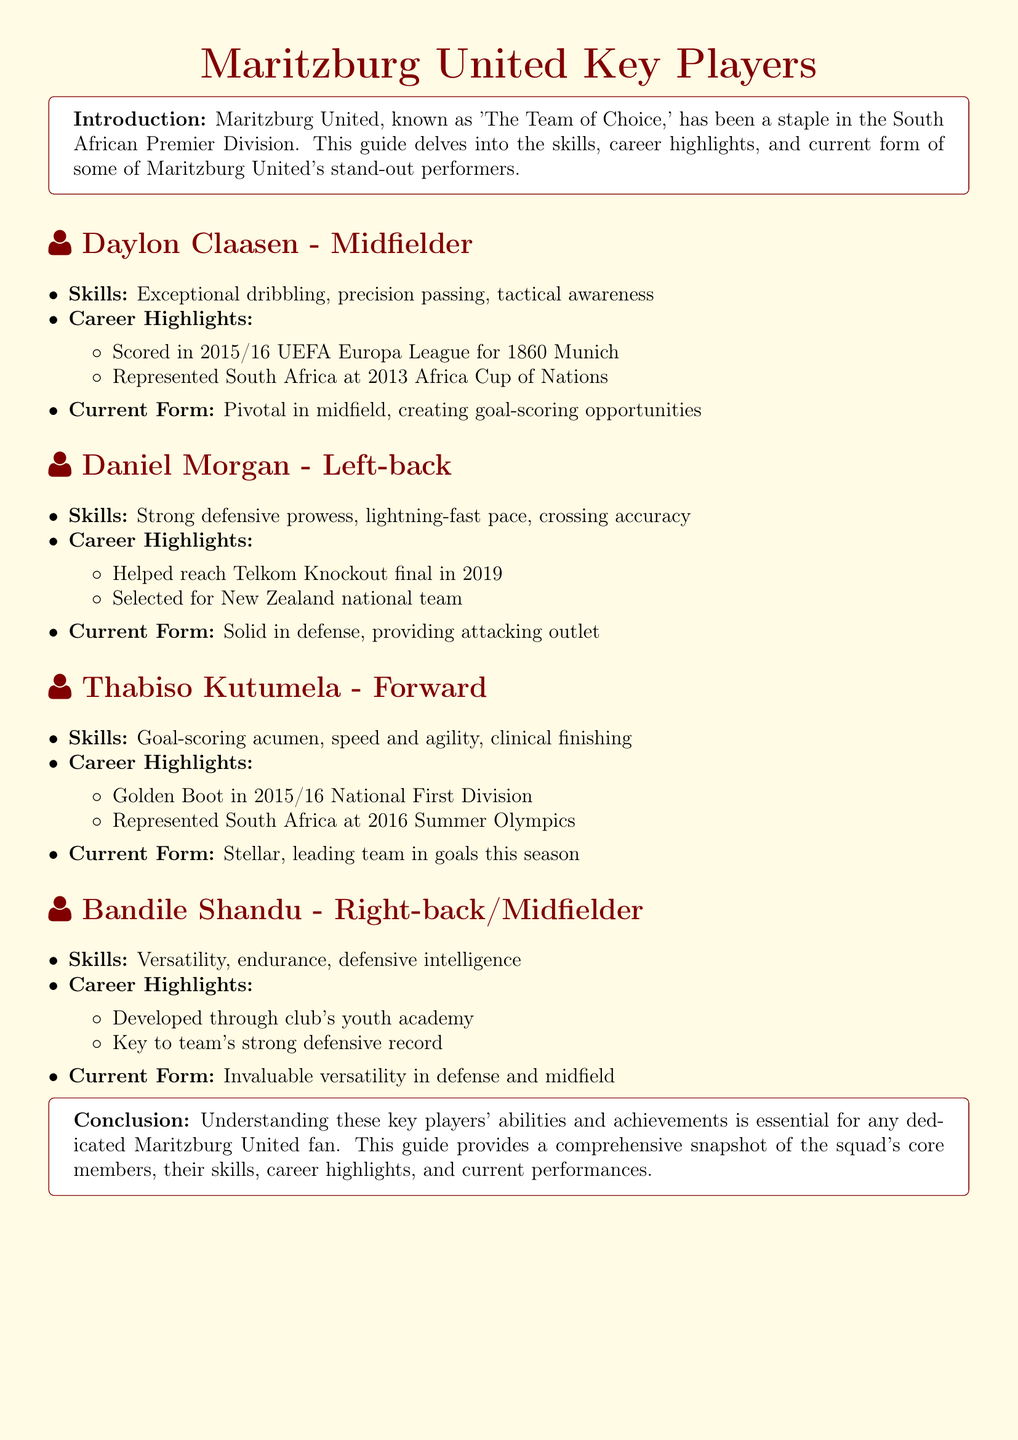What position does Daylon Claasen play? Daylon Claasen is identified as a midfielder in the document.
Answer: Midfielder What career highlight is associated with Thabiso Kutumela? Thabiso Kutumela is noted for winning the Golden Boot in the 2015/16 National First Division.
Answer: Golden Boot in 2015/16 National First Division What skill is highlighted for Daniel Morgan? The document highlights Daniel Morgan's strong defensive prowess as one of his key skills.
Answer: Strong defensive prowess Who represents South Africa at the 2016 Summer Olympics? Thabiso Kutumela is the player mentioned who represented South Africa at the 2016 Summer Olympics.
Answer: Thabiso Kutumela Which player has been developed through the club's youth academy? Bandile Shandu is mentioned as a player who developed through the club's youth academy.
Answer: Bandile Shandu What is Daylon Claasen's current form described as? Daylon Claasen's current form is described as pivotal in midfield, creating goal-scoring opportunities.
Answer: Pivotal in midfield How many career highlights are listed for Daniel Morgan? There are two career highlights listed for Daniel Morgan in the document.
Answer: Two What is the primary defensive role of Bandile Shandu? Bandile Shandu plays a role as a right-back/midfielder in the team.
Answer: Right-back/Midfielder What is the purpose of this guide? The purpose of the guide is to provide a comprehensive snapshot of Maritzburg United's key players.
Answer: Comprehensive snapshot of key players 